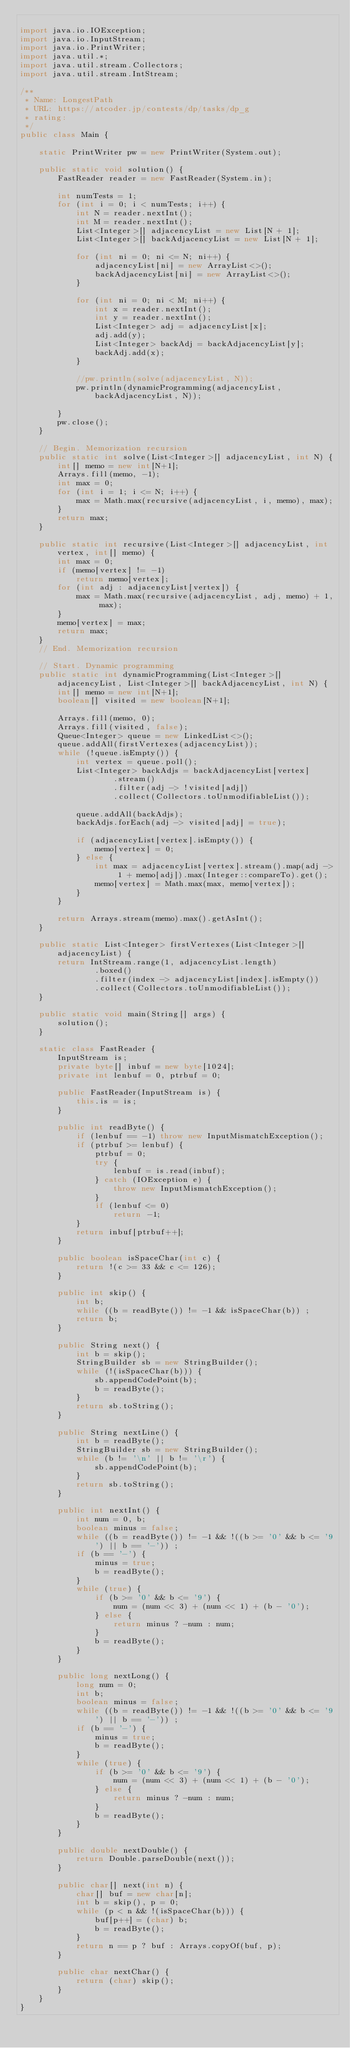<code> <loc_0><loc_0><loc_500><loc_500><_Java_>
import java.io.IOException;
import java.io.InputStream;
import java.io.PrintWriter;
import java.util.*;
import java.util.stream.Collectors;
import java.util.stream.IntStream;

/**
 * Name: LongestPath
 * URL: https://atcoder.jp/contests/dp/tasks/dp_g
 * rating:
 */
public class Main {

    static PrintWriter pw = new PrintWriter(System.out);

    public static void solution() {
        FastReader reader = new FastReader(System.in);

        int numTests = 1;
        for (int i = 0; i < numTests; i++) {
            int N = reader.nextInt();
            int M = reader.nextInt();
            List<Integer>[] adjacencyList = new List[N + 1];
            List<Integer>[] backAdjacencyList = new List[N + 1];

            for (int ni = 0; ni <= N; ni++) {
                adjacencyList[ni] = new ArrayList<>();
                backAdjacencyList[ni] = new ArrayList<>();
            }

            for (int ni = 0; ni < M; ni++) {
                int x = reader.nextInt();
                int y = reader.nextInt();
                List<Integer> adj = adjacencyList[x];
                adj.add(y);
                List<Integer> backAdj = backAdjacencyList[y];
                backAdj.add(x);
            }

            //pw.println(solve(adjacencyList, N));
            pw.println(dynamicProgramming(adjacencyList, backAdjacencyList, N));

        }
        pw.close();
    }

    // Begin. Memorization recursion
    public static int solve(List<Integer>[] adjacencyList, int N) {
        int[] memo = new int[N+1];
        Arrays.fill(memo, -1);
        int max = 0;
        for (int i = 1; i <= N; i++) {
            max = Math.max(recursive(adjacencyList, i, memo), max);
        }
        return max;
    }

    public static int recursive(List<Integer>[] adjacencyList, int vertex, int[] memo) {
        int max = 0;
        if (memo[vertex] != -1)
            return memo[vertex];
        for (int adj : adjacencyList[vertex]) {
            max = Math.max(recursive(adjacencyList, adj, memo) + 1, max);
        }
        memo[vertex] = max;
        return max;
    }
    // End. Memorization recursion

    // Start. Dynamic programming
    public static int dynamicProgramming(List<Integer>[] adjacencyList, List<Integer>[] backAdjacencyList, int N) {
        int[] memo = new int[N+1];
        boolean[] visited = new boolean[N+1];

        Arrays.fill(memo, 0);
        Arrays.fill(visited, false);
        Queue<Integer> queue = new LinkedList<>();
        queue.addAll(firstVertexes(adjacencyList));
        while (!queue.isEmpty()) {
            int vertex = queue.poll();
            List<Integer> backAdjs = backAdjacencyList[vertex]
                    .stream()
                    .filter(adj -> !visited[adj])
                    .collect(Collectors.toUnmodifiableList());

            queue.addAll(backAdjs);
            backAdjs.forEach(adj -> visited[adj] = true);

            if (adjacencyList[vertex].isEmpty()) {
                memo[vertex] = 0;
            } else {
                int max = adjacencyList[vertex].stream().map(adj -> 1 + memo[adj]).max(Integer::compareTo).get();
                memo[vertex] = Math.max(max, memo[vertex]);
            }
        }

        return Arrays.stream(memo).max().getAsInt();
    }

    public static List<Integer> firstVertexes(List<Integer>[] adjacencyList) {
        return IntStream.range(1, adjacencyList.length)
                .boxed()
                .filter(index -> adjacencyList[index].isEmpty())
                .collect(Collectors.toUnmodifiableList());
    }

    public static void main(String[] args) {
        solution();
    }

    static class FastReader {
        InputStream is;
        private byte[] inbuf = new byte[1024];
        private int lenbuf = 0, ptrbuf = 0;

        public FastReader(InputStream is) {
            this.is = is;
        }

        public int readByte() {
            if (lenbuf == -1) throw new InputMismatchException();
            if (ptrbuf >= lenbuf) {
                ptrbuf = 0;
                try {
                    lenbuf = is.read(inbuf);
                } catch (IOException e) {
                    throw new InputMismatchException();
                }
                if (lenbuf <= 0)
                    return -1;
            }
            return inbuf[ptrbuf++];
        }

        public boolean isSpaceChar(int c) {
            return !(c >= 33 && c <= 126);
        }

        public int skip() {
            int b;
            while ((b = readByte()) != -1 && isSpaceChar(b)) ;
            return b;
        }

        public String next() {
            int b = skip();
            StringBuilder sb = new StringBuilder();
            while (!(isSpaceChar(b))) {
                sb.appendCodePoint(b);
                b = readByte();
            }
            return sb.toString();
        }

        public String nextLine() {
            int b = readByte();
            StringBuilder sb = new StringBuilder();
            while (b != '\n' || b != '\r') {
                sb.appendCodePoint(b);
            }
            return sb.toString();
        }

        public int nextInt() {
            int num = 0, b;
            boolean minus = false;
            while ((b = readByte()) != -1 && !((b >= '0' && b <= '9') || b == '-')) ;
            if (b == '-') {
                minus = true;
                b = readByte();
            }
            while (true) {
                if (b >= '0' && b <= '9') {
                    num = (num << 3) + (num << 1) + (b - '0');
                } else {
                    return minus ? -num : num;
                }
                b = readByte();
            }
        }

        public long nextLong() {
            long num = 0;
            int b;
            boolean minus = false;
            while ((b = readByte()) != -1 && !((b >= '0' && b <= '9') || b == '-')) ;
            if (b == '-') {
                minus = true;
                b = readByte();
            }
            while (true) {
                if (b >= '0' && b <= '9') {
                    num = (num << 3) + (num << 1) + (b - '0');
                } else {
                    return minus ? -num : num;
                }
                b = readByte();
            }
        }

        public double nextDouble() {
            return Double.parseDouble(next());
        }

        public char[] next(int n) {
            char[] buf = new char[n];
            int b = skip(), p = 0;
            while (p < n && !(isSpaceChar(b))) {
                buf[p++] = (char) b;
                b = readByte();
            }
            return n == p ? buf : Arrays.copyOf(buf, p);
        }

        public char nextChar() {
            return (char) skip();
        }
    }
}
</code> 